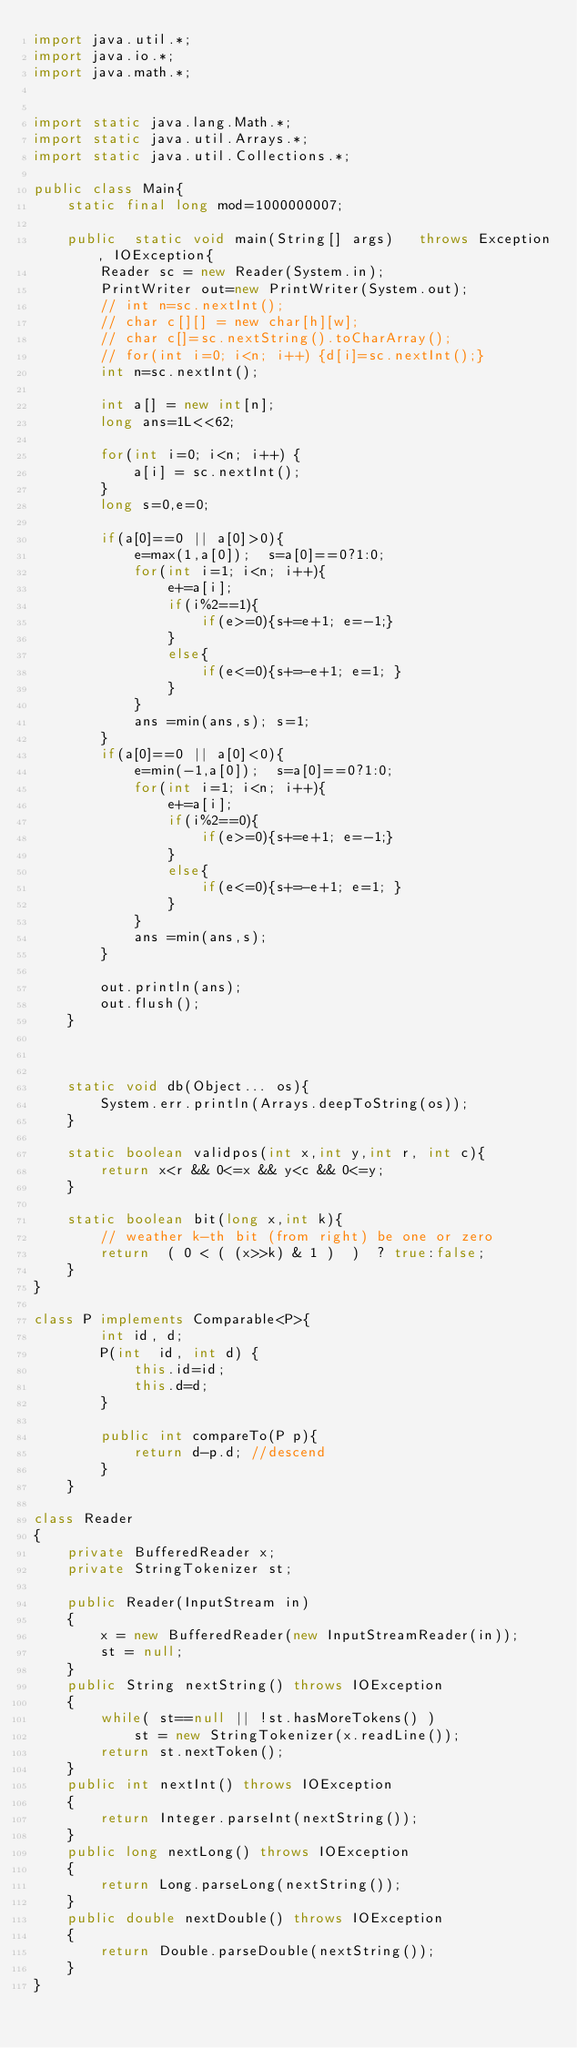Convert code to text. <code><loc_0><loc_0><loc_500><loc_500><_Java_>import java.util.*;
import java.io.*;
import java.math.*;
 
 
import static java.lang.Math.*;
import static java.util.Arrays.*;
import static java.util.Collections.*;
 
public class Main{
    static final long mod=1000000007;
    
    public  static void main(String[] args)   throws Exception, IOException{
        Reader sc = new Reader(System.in);
        PrintWriter out=new PrintWriter(System.out);
        // int n=sc.nextInt();
        // char c[][] = new char[h][w];
        // char c[]=sc.nextString().toCharArray();
        // for(int i=0; i<n; i++) {d[i]=sc.nextInt();}
        int n=sc.nextInt();

        int a[] = new int[n];
        long ans=1L<<62;

        for(int i=0; i<n; i++) {
            a[i] = sc.nextInt();
        }
        long s=0,e=0;

        if(a[0]==0 || a[0]>0){
            e=max(1,a[0]);  s=a[0]==0?1:0;
            for(int i=1; i<n; i++){
                e+=a[i];
                if(i%2==1){
                    if(e>=0){s+=e+1; e=-1;}
                }
                else{
                    if(e<=0){s+=-e+1; e=1; }
                }
            }
            ans =min(ans,s); s=1;
        }
        if(a[0]==0 || a[0]<0){
            e=min(-1,a[0]);  s=a[0]==0?1:0;
            for(int i=1; i<n; i++){
                e+=a[i];
                if(i%2==0){
                    if(e>=0){s+=e+1; e=-1;}
                }
                else{
                    if(e<=0){s+=-e+1; e=1; }
                }
            }
            ans =min(ans,s); 
        }

        out.println(ans);
        out.flush();
    }



    static void db(Object... os){
        System.err.println(Arrays.deepToString(os));
    }
     
    static boolean validpos(int x,int y,int r, int c){
        return x<r && 0<=x && y<c && 0<=y;
    }
    
    static boolean bit(long x,int k){
        // weather k-th bit (from right) be one or zero
        return  ( 0 < ( (x>>k) & 1 )  )  ? true:false;
    }    
}

class P implements Comparable<P>{
        int id, d;
        P(int  id, int d) {
            this.id=id;
            this.d=d;
        } 
          
        public int compareTo(P p){
            return d-p.d; //descend
        }
    }

class Reader
{ 
    private BufferedReader x;
    private StringTokenizer st;
    
    public Reader(InputStream in)
    {
        x = new BufferedReader(new InputStreamReader(in));
        st = null;
    }
    public String nextString() throws IOException
    {
        while( st==null || !st.hasMoreTokens() )
            st = new StringTokenizer(x.readLine());
        return st.nextToken();
    }
    public int nextInt() throws IOException
    {
        return Integer.parseInt(nextString());
    }
    public long nextLong() throws IOException
    {
        return Long.parseLong(nextString());
    }
    public double nextDouble() throws IOException
    {
        return Double.parseDouble(nextString());
    }
}</code> 